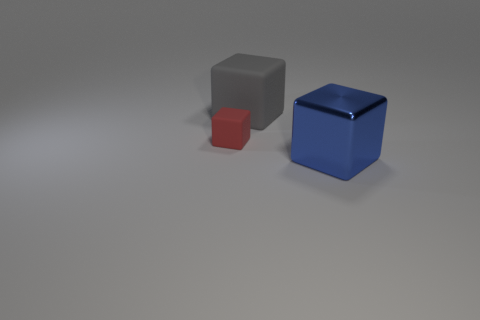Add 2 large blue rubber objects. How many objects exist? 5 Add 2 blue shiny things. How many blue shiny things are left? 3 Add 2 small red matte cubes. How many small red matte cubes exist? 3 Subtract 0 red cylinders. How many objects are left? 3 Subtract all large metallic blocks. Subtract all gray things. How many objects are left? 1 